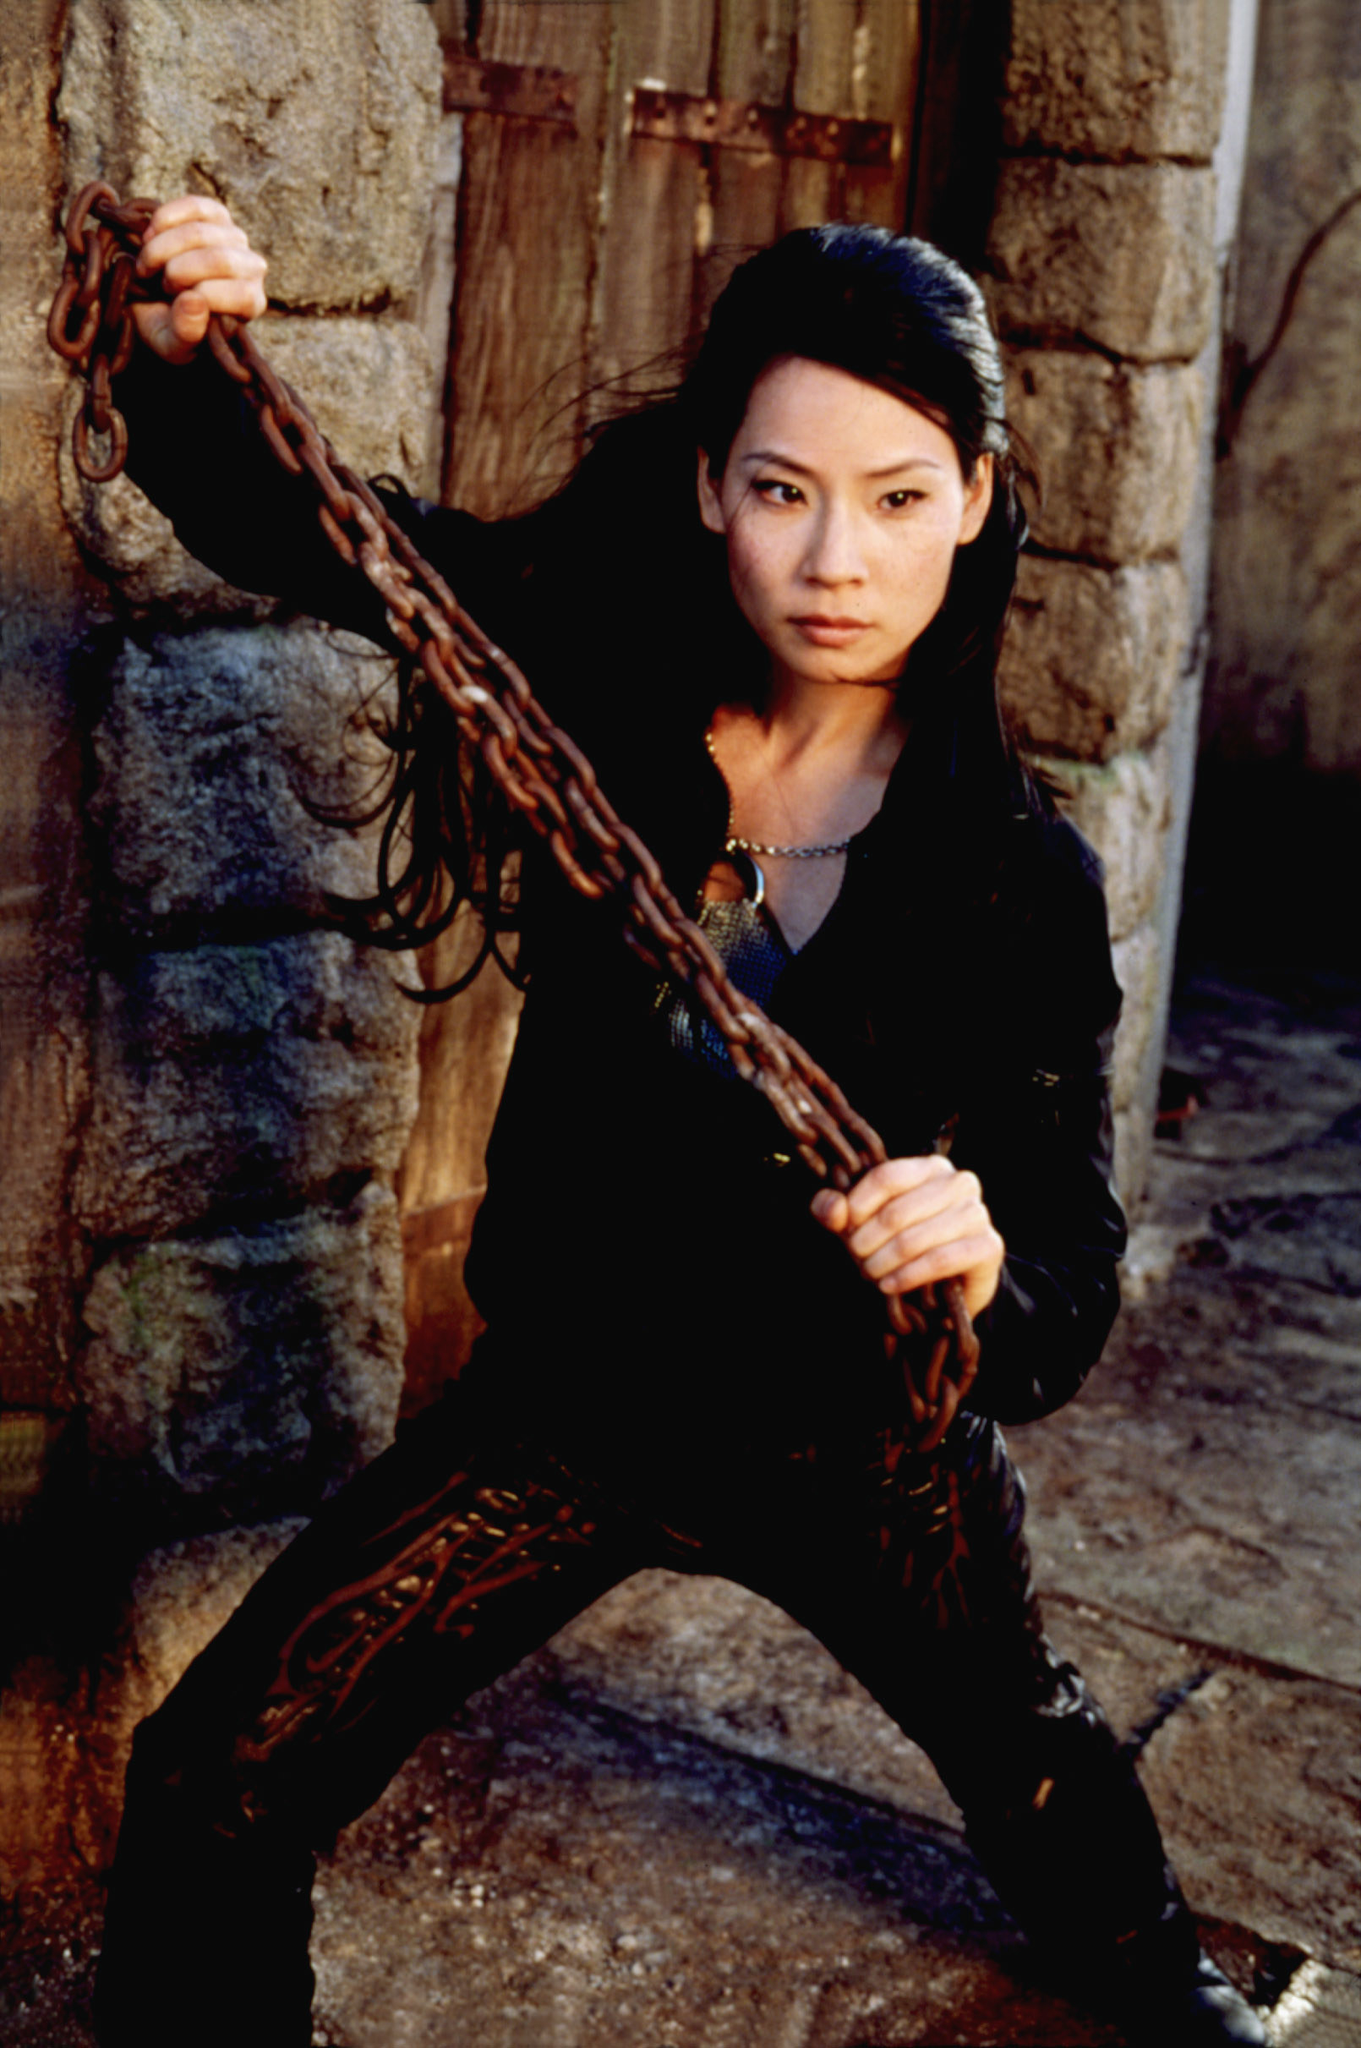What can you tell me about the setting in this image? The setting of the image appears to be a rugged, possibly historical or abandoned location. The stone wall and wooden door suggest an old structure, perhaps a fortress or ancient building. The rough textures and earthy tones of the surroundings contribute to a sense of age and durability. This setting provides a stark backdrop that emphasizes the character's modern attire and the tension within the scene. Describe the ambiance and atmosphere created by the background. The background of the image creates an ambiance of mystery and history. The stone wall and weathered wooden door give the impression of a place with many stories to tell. The rugged, unrefined appearance of the setting contrasts with the character's sleek outfit, adding an element of intrigue. The atmosphere is charged with a sense of past conflicts or hidden secrets, evoking curiosity about what has transpired in this location. Imagine there's a hidden story behind this setting. What might it be? This setting could be the remnants of a once-great citadel, now shrouded in legend and mystery. Long ago, it was the stronghold of a powerful order of knights entrusted with guarding an ancient relic of immense power. Over the centuries, the citadel fell into ruin, and the relic was forgotten by most. However, whispers of its power persisted, drawing seekers and adventurers hoping to claim its secrets. The character in the image could be one of the few who remember the truth, standing guard against those who would misuse the relic's power. Her presence here signifies a connection to this hidden past and a duty to protect its legacy at all costs. 